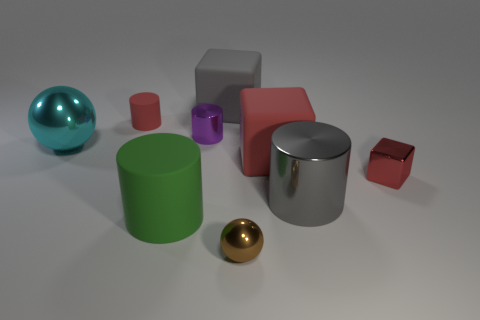Is the number of shiny blocks that are to the left of the large red block the same as the number of small shiny things that are in front of the large cyan shiny object?
Your answer should be compact. No. What is the shape of the metal thing that is right of the green matte thing and behind the large red rubber object?
Your answer should be compact. Cylinder. There is a large gray cube; how many rubber objects are left of it?
Make the answer very short. 2. How many other objects are the same shape as the tiny rubber thing?
Give a very brief answer. 3. Is the number of gray metallic cylinders less than the number of big matte cubes?
Make the answer very short. Yes. What size is the cylinder that is left of the purple metal cylinder and in front of the red matte cylinder?
Ensure brevity in your answer.  Large. What is the size of the rubber block behind the shiny sphere left of the ball right of the cyan object?
Offer a very short reply. Large. The green matte thing is what size?
Keep it short and to the point. Large. Are there any tiny metal blocks in front of the large shiny object on the left side of the metal cylinder that is in front of the red metal block?
Provide a succinct answer. Yes. What number of large objects are either matte objects or red matte cylinders?
Provide a short and direct response. 3. 